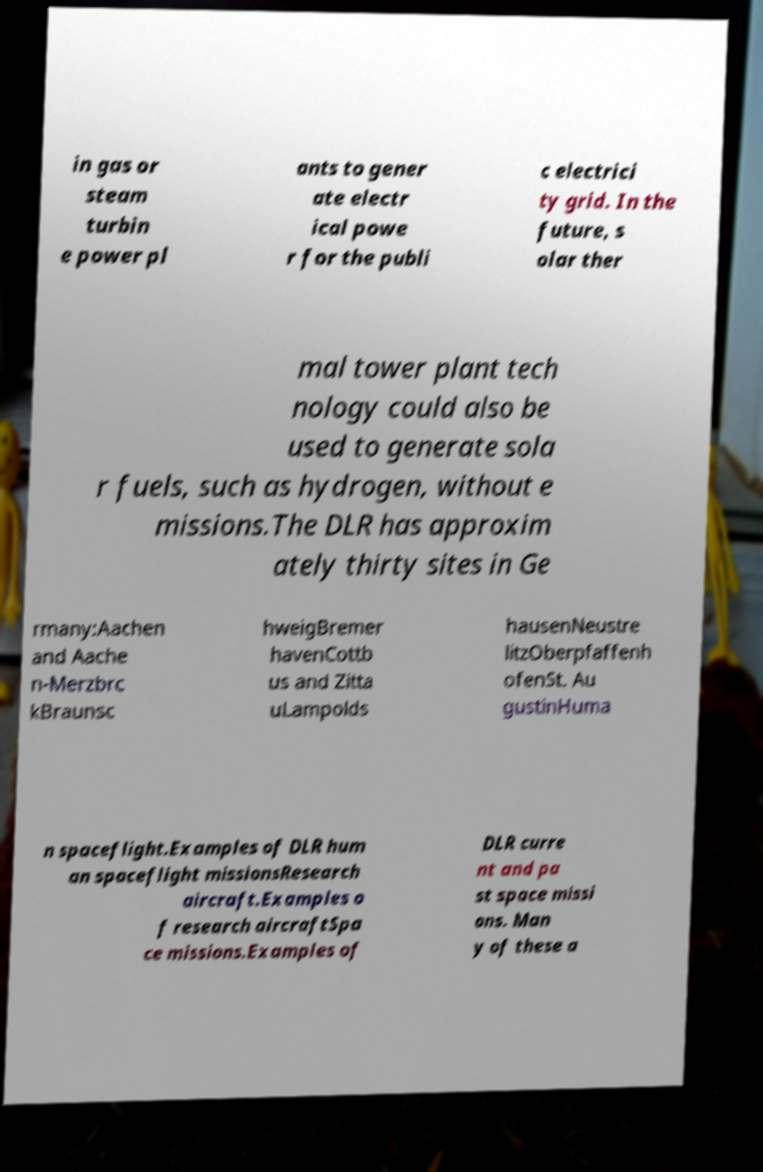What messages or text are displayed in this image? I need them in a readable, typed format. in gas or steam turbin e power pl ants to gener ate electr ical powe r for the publi c electrici ty grid. In the future, s olar ther mal tower plant tech nology could also be used to generate sola r fuels, such as hydrogen, without e missions.The DLR has approxim ately thirty sites in Ge rmany:Aachen and Aache n-Merzbrc kBraunsc hweigBremer havenCottb us and Zitta uLampolds hausenNeustre litzOberpfaffenh ofenSt. Au gustinHuma n spaceflight.Examples of DLR hum an spaceflight missionsResearch aircraft.Examples o f research aircraftSpa ce missions.Examples of DLR curre nt and pa st space missi ons. Man y of these a 